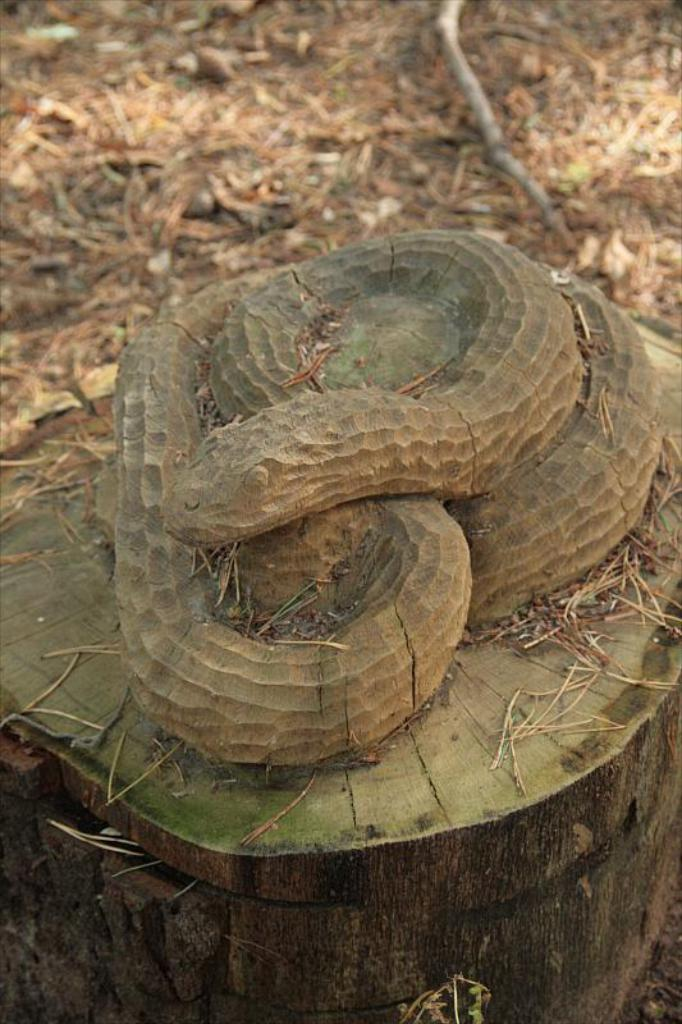What is the main subject of the image? There is a snake sculpture in the image. Where is the snake sculpture located? The snake sculpture is on a wooden trunk. What type of vegetation can be seen in the image? There is: There is grass visible in the image. On what surface is the grass located? The grass is on the land. Can you see an owl perched on the snake sculpture in the image? No, there is no owl present in the image. What type of journey is depicted in the image? There is no journey depicted in the image; it features a snake sculpture on a wooden trunk with grass in the background. 